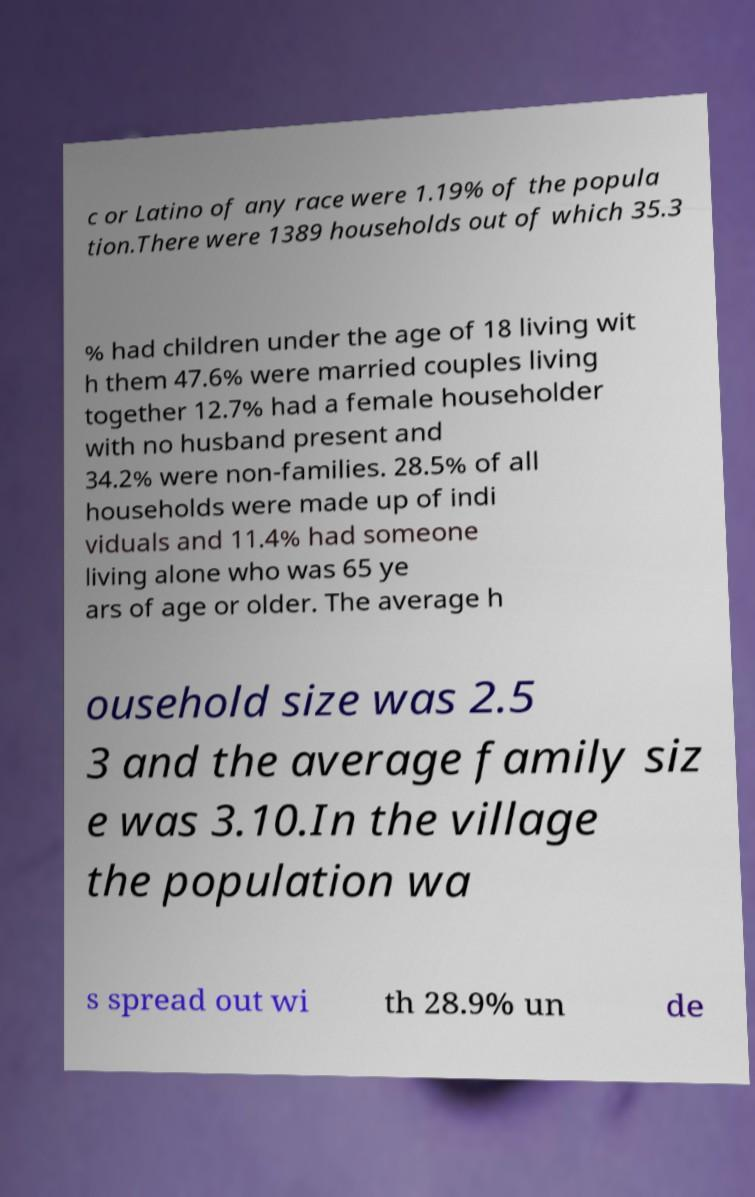For documentation purposes, I need the text within this image transcribed. Could you provide that? c or Latino of any race were 1.19% of the popula tion.There were 1389 households out of which 35.3 % had children under the age of 18 living wit h them 47.6% were married couples living together 12.7% had a female householder with no husband present and 34.2% were non-families. 28.5% of all households were made up of indi viduals and 11.4% had someone living alone who was 65 ye ars of age or older. The average h ousehold size was 2.5 3 and the average family siz e was 3.10.In the village the population wa s spread out wi th 28.9% un de 